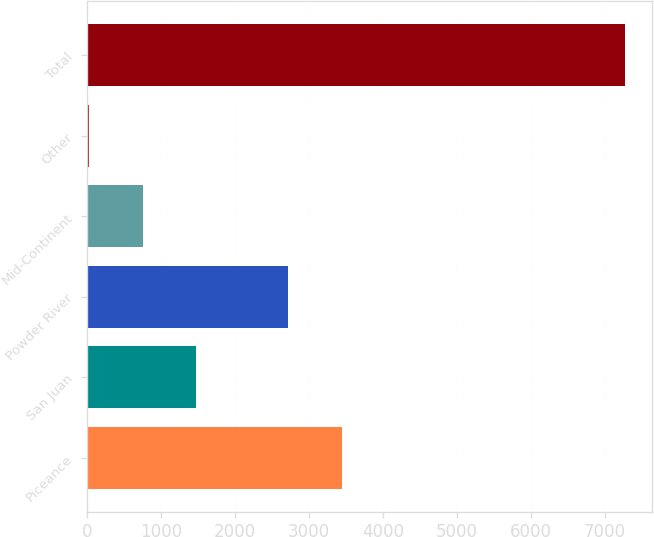Convert chart. <chart><loc_0><loc_0><loc_500><loc_500><bar_chart><fcel>Piceance<fcel>San Juan<fcel>Powder River<fcel>Mid-Continent<fcel>Other<fcel>Total<nl><fcel>3446.6<fcel>1476.2<fcel>2722<fcel>751.6<fcel>27<fcel>7273<nl></chart> 